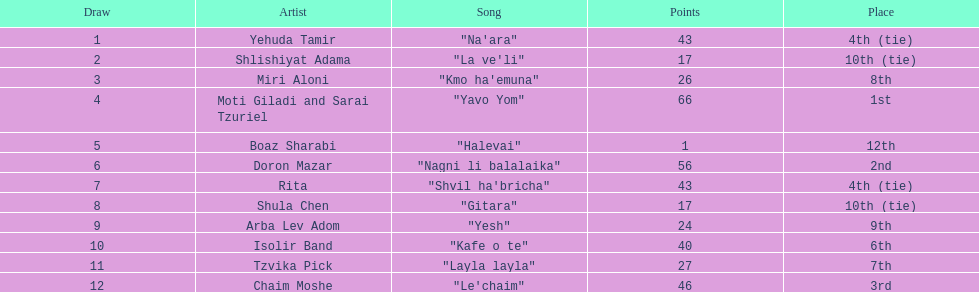What is the name of the foremost track listed on this chart? "Na'ara". 